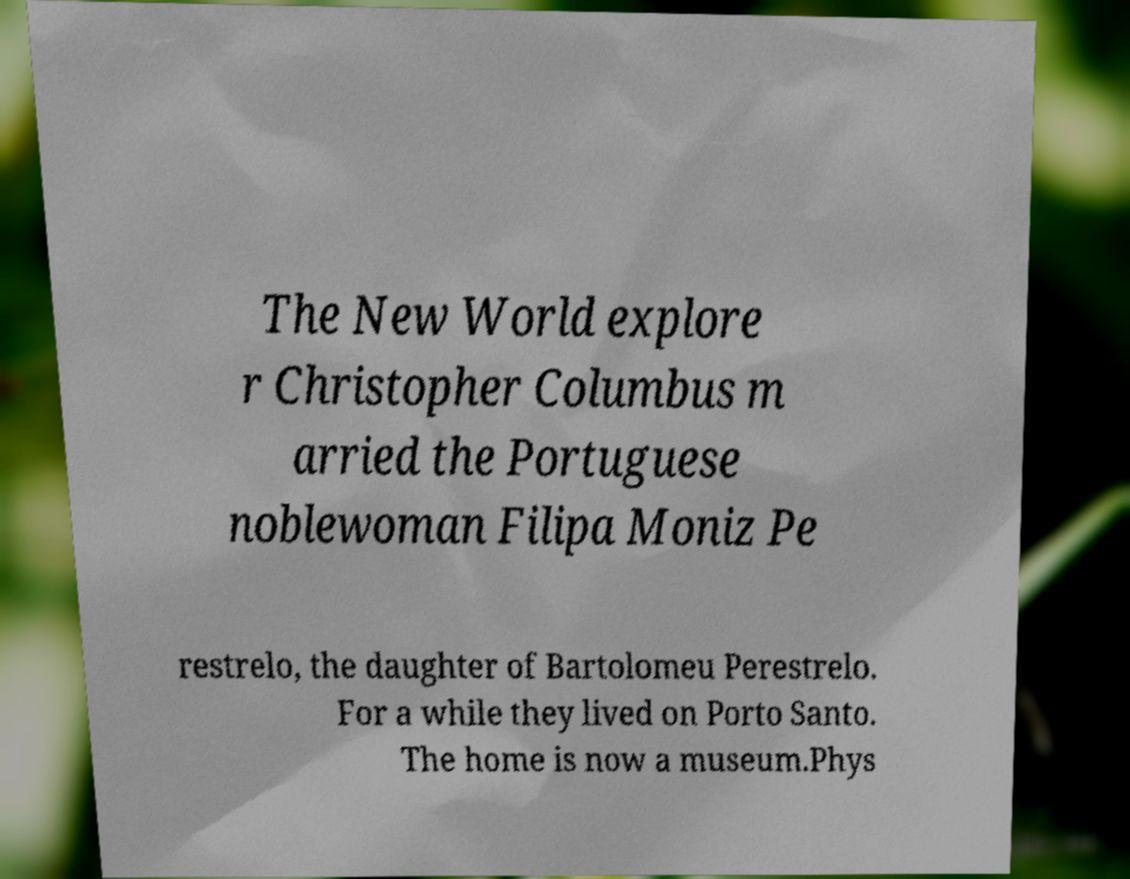Please identify and transcribe the text found in this image. The New World explore r Christopher Columbus m arried the Portuguese noblewoman Filipa Moniz Pe restrelo, the daughter of Bartolomeu Perestrelo. For a while they lived on Porto Santo. The home is now a museum.Phys 